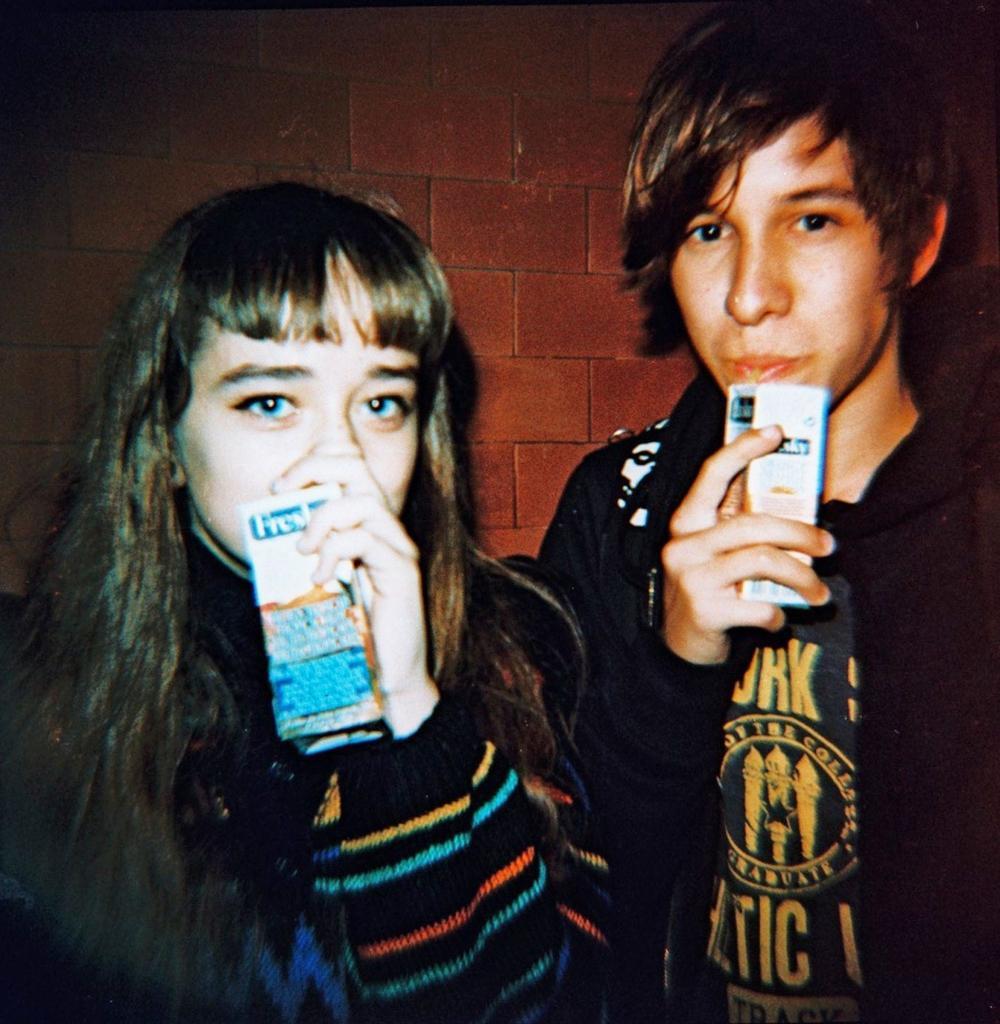How would you summarize this image in a sentence or two? There are two members here, the right side one is a boy and the left side one is a girl. Both of them are drinking juices with a straws inserted. The guy is wearing a t shirt and a hoodie. The girl is wearing a sweater. The girl hair is long and below the shoulders. There is a wall behind them which is constructed with a red blocks. 